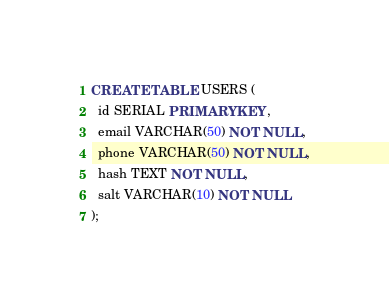Convert code to text. <code><loc_0><loc_0><loc_500><loc_500><_SQL_>CREATE TABLE USERS (
  id SERIAL PRIMARY KEY,
  email VARCHAR(50) NOT NULL,
  phone VARCHAR(50) NOT NULL,
  hash TEXT NOT NULL,
  salt VARCHAR(10) NOT NULL
);</code> 